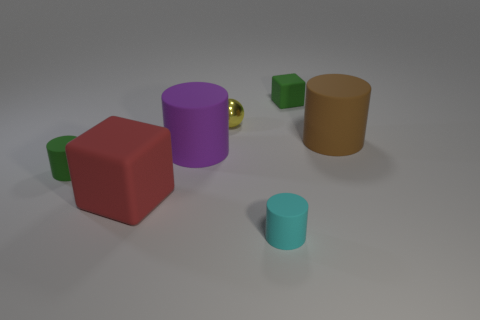Is the color of the large matte cube the same as the metallic ball?
Give a very brief answer. No. What number of objects are either large things that are left of the small cyan object or small yellow objects?
Your response must be concise. 3. How many rubber objects are in front of the green thing that is in front of the brown matte thing?
Your answer should be very brief. 2. What size is the green object on the left side of the tiny green rubber object that is behind the big brown matte cylinder that is to the right of the large purple object?
Keep it short and to the point. Small. There is a small cylinder right of the tiny yellow sphere; is it the same color as the ball?
Make the answer very short. No. The cyan thing that is the same shape as the purple rubber object is what size?
Keep it short and to the point. Small. What number of things are either things on the left side of the big purple matte thing or matte cylinders left of the ball?
Provide a succinct answer. 3. There is a small thing in front of the red rubber cube in front of the yellow metal ball; what shape is it?
Provide a short and direct response. Cylinder. Is there anything else that is the same color as the large rubber block?
Offer a very short reply. No. Are there any other things that are the same size as the green cube?
Your response must be concise. Yes. 